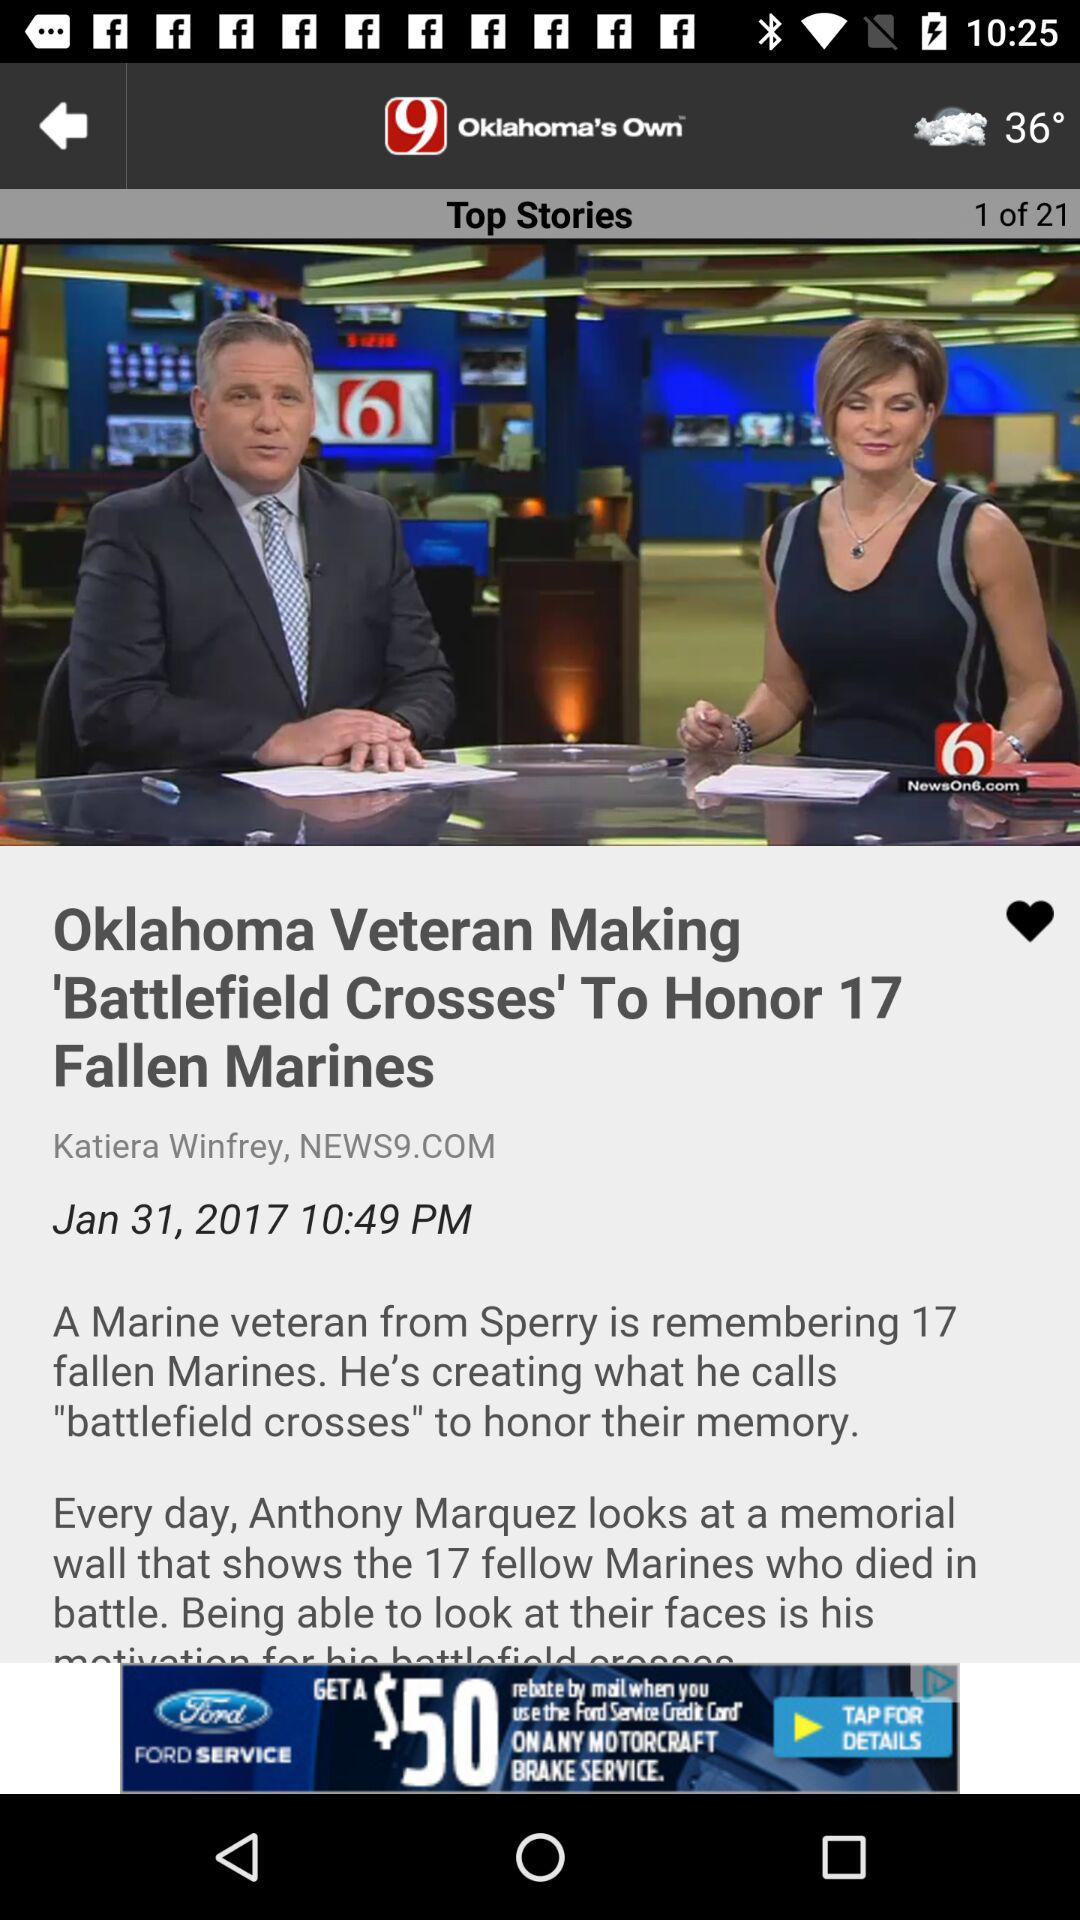What is the temperature? The temperature is 36°. 